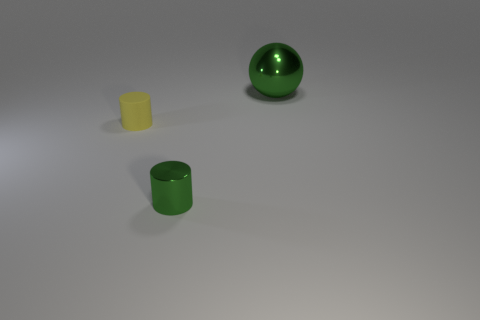Subtract all yellow cylinders. How many cylinders are left? 1 Subtract 1 cylinders. How many cylinders are left? 1 Add 2 small green cylinders. How many objects exist? 5 Subtract all cylinders. How many objects are left? 1 Subtract all yellow cubes. How many yellow cylinders are left? 1 Subtract 0 red cylinders. How many objects are left? 3 Subtract all cyan spheres. Subtract all blue cylinders. How many spheres are left? 1 Subtract all blue objects. Subtract all spheres. How many objects are left? 2 Add 2 cylinders. How many cylinders are left? 4 Add 2 brown shiny objects. How many brown shiny objects exist? 2 